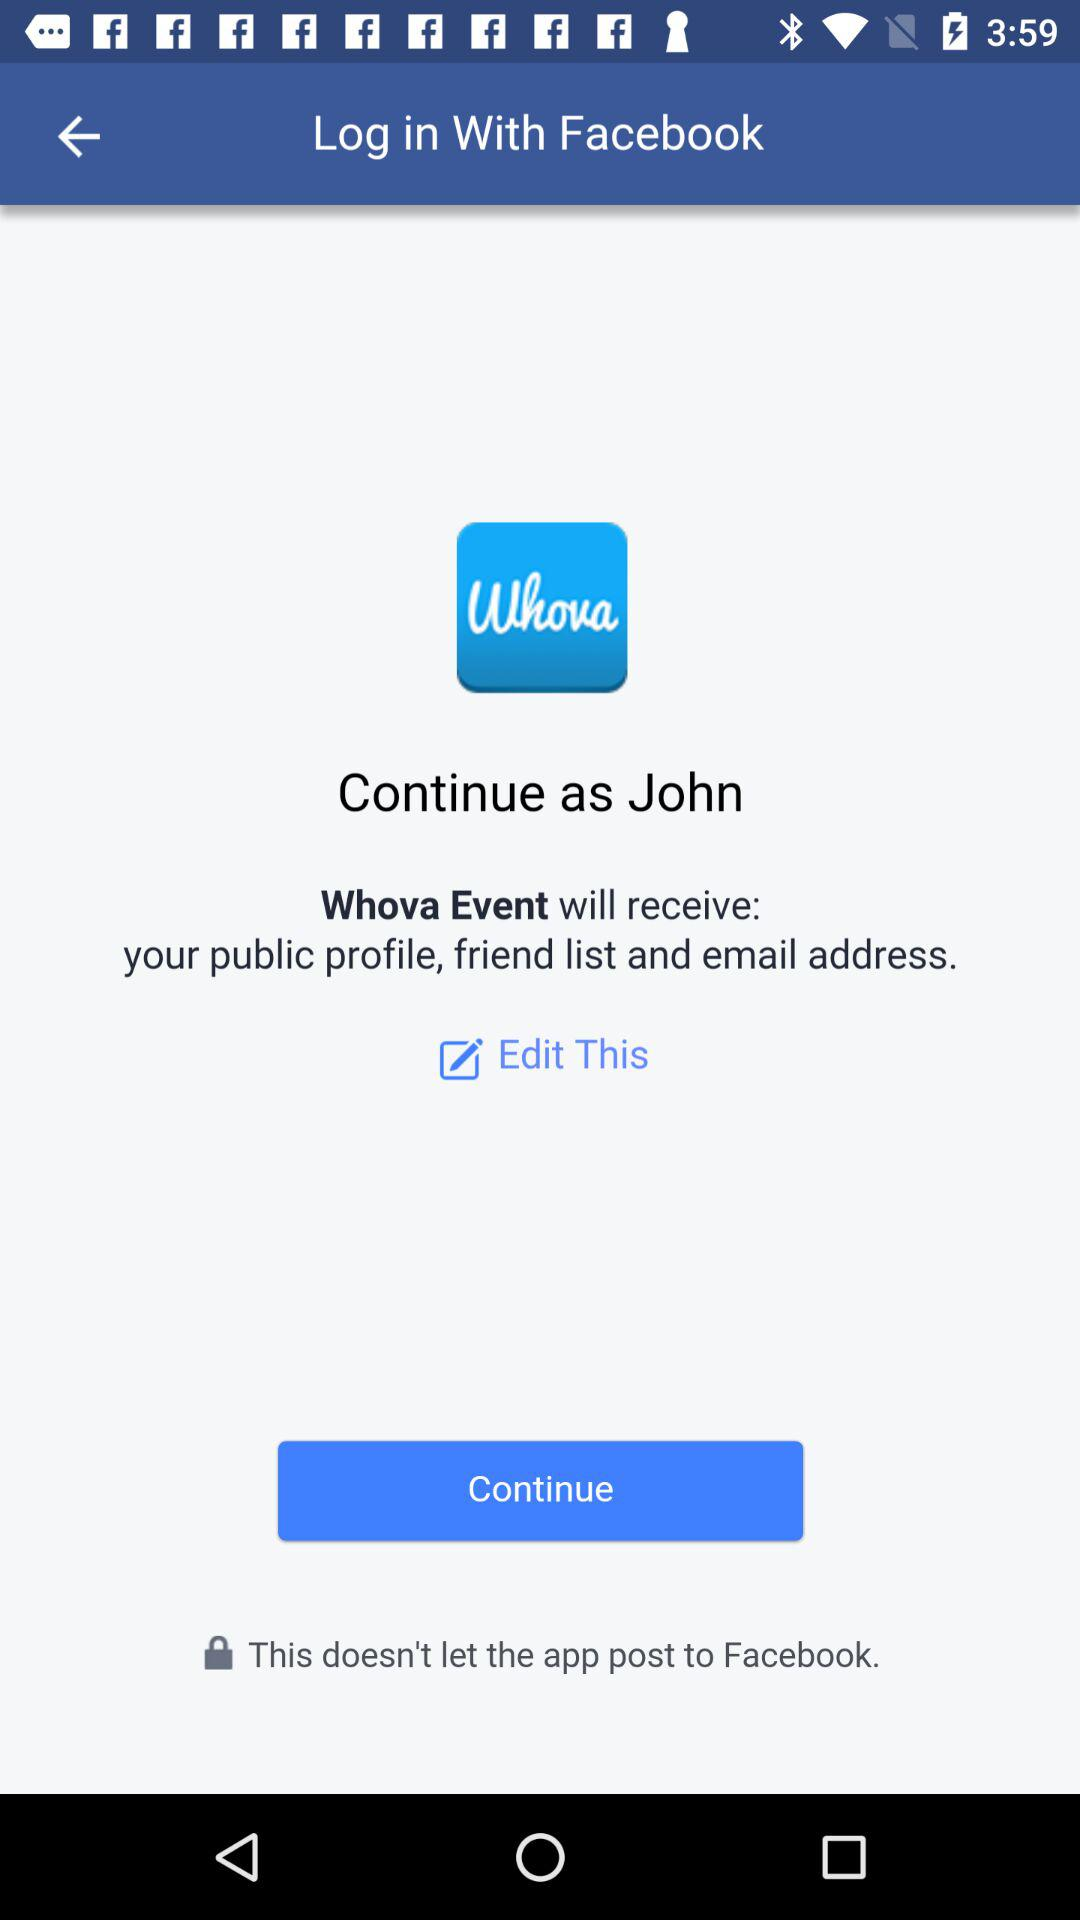Which email address will "Whova Event" have access to?
When the provided information is insufficient, respond with <no answer>. <no answer> 